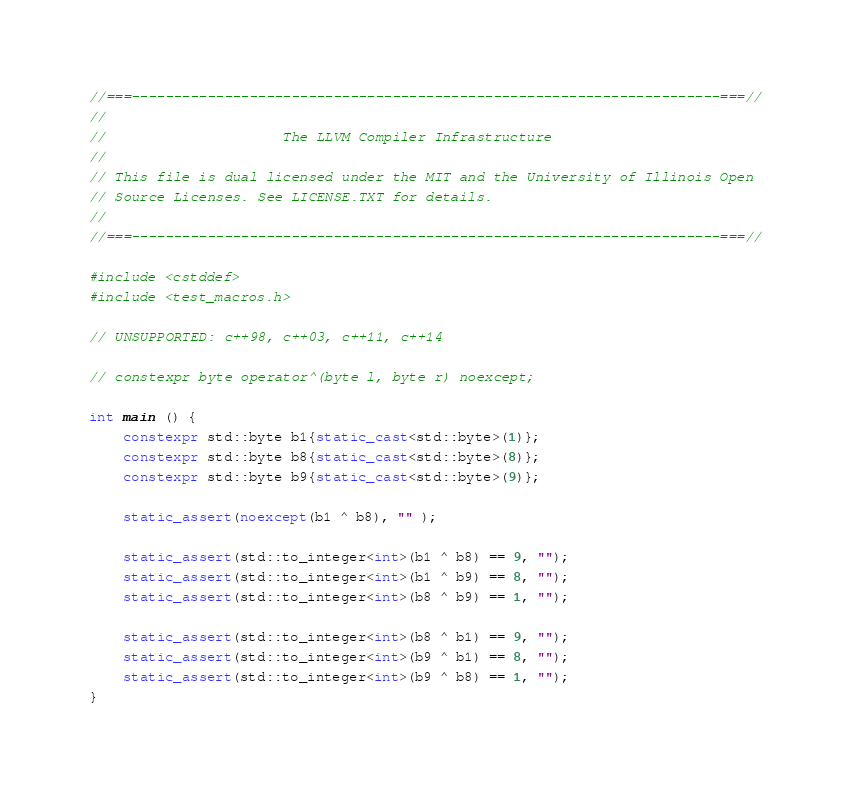Convert code to text. <code><loc_0><loc_0><loc_500><loc_500><_C++_>//===----------------------------------------------------------------------===//
//
//                     The LLVM Compiler Infrastructure
//
// This file is dual licensed under the MIT and the University of Illinois Open
// Source Licenses. See LICENSE.TXT for details.
//
//===----------------------------------------------------------------------===//

#include <cstddef>
#include <test_macros.h>

// UNSUPPORTED: c++98, c++03, c++11, c++14

// constexpr byte operator^(byte l, byte r) noexcept;

int main () {
	constexpr std::byte b1{static_cast<std::byte>(1)};
	constexpr std::byte b8{static_cast<std::byte>(8)};
	constexpr std::byte b9{static_cast<std::byte>(9)};

	static_assert(noexcept(b1 ^ b8), "" );

	static_assert(std::to_integer<int>(b1 ^ b8) == 9, "");
	static_assert(std::to_integer<int>(b1 ^ b9) == 8, "");
	static_assert(std::to_integer<int>(b8 ^ b9) == 1, "");

	static_assert(std::to_integer<int>(b8 ^ b1) == 9, "");
	static_assert(std::to_integer<int>(b9 ^ b1) == 8, "");
	static_assert(std::to_integer<int>(b9 ^ b8) == 1, "");
}
</code> 